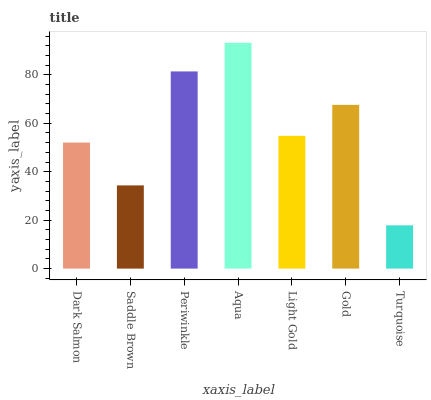Is Turquoise the minimum?
Answer yes or no. Yes. Is Aqua the maximum?
Answer yes or no. Yes. Is Saddle Brown the minimum?
Answer yes or no. No. Is Saddle Brown the maximum?
Answer yes or no. No. Is Dark Salmon greater than Saddle Brown?
Answer yes or no. Yes. Is Saddle Brown less than Dark Salmon?
Answer yes or no. Yes. Is Saddle Brown greater than Dark Salmon?
Answer yes or no. No. Is Dark Salmon less than Saddle Brown?
Answer yes or no. No. Is Light Gold the high median?
Answer yes or no. Yes. Is Light Gold the low median?
Answer yes or no. Yes. Is Aqua the high median?
Answer yes or no. No. Is Gold the low median?
Answer yes or no. No. 